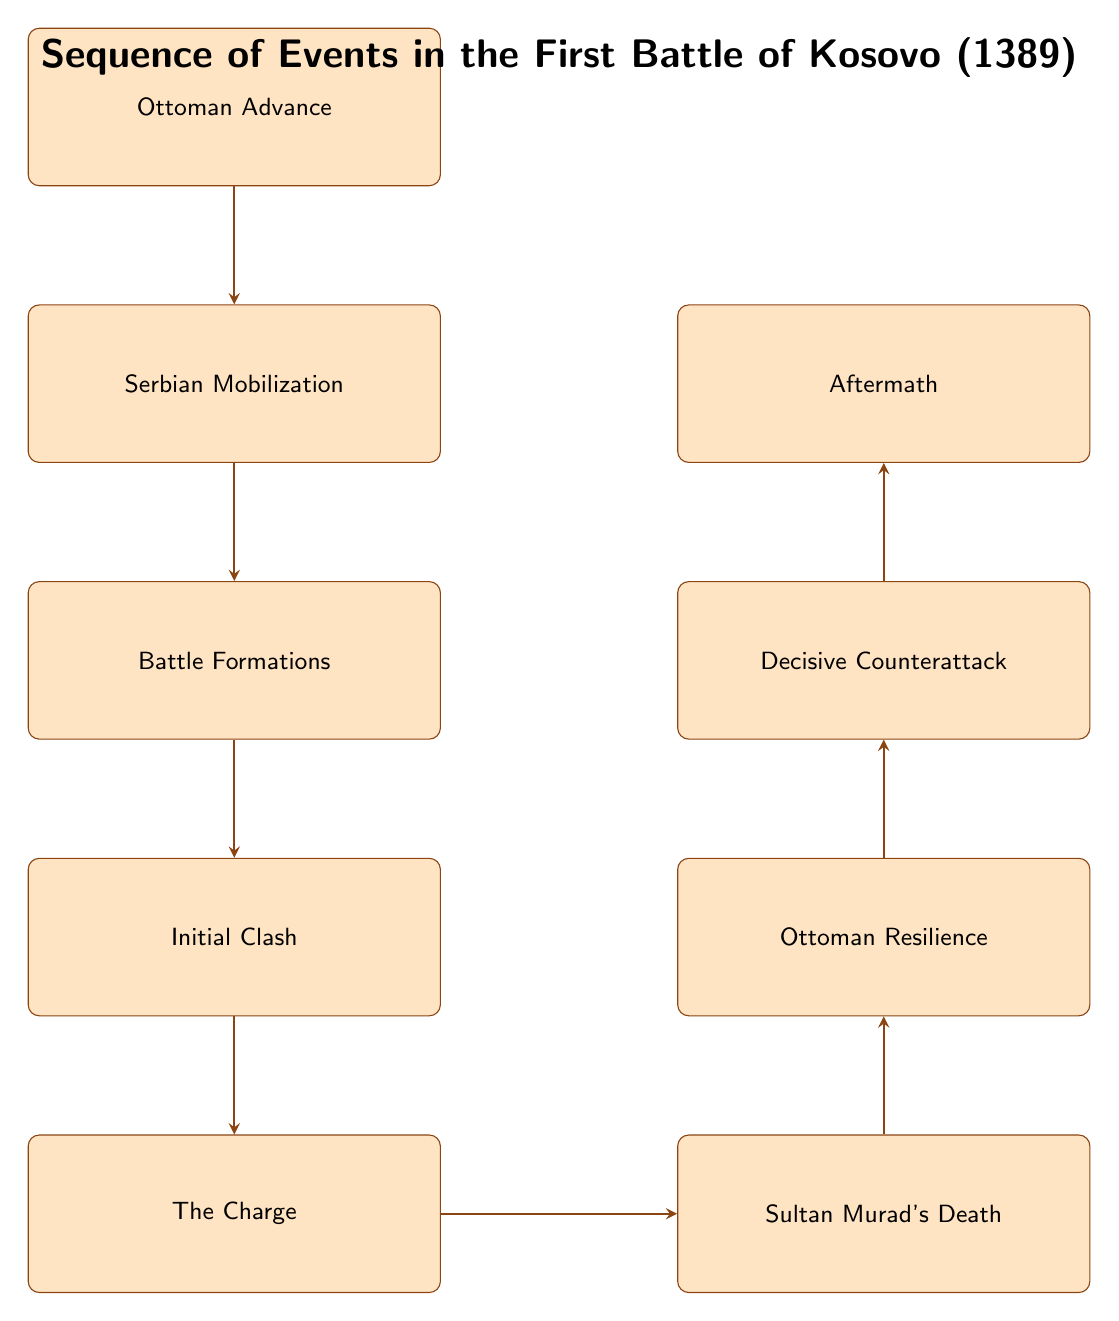What is the first event in the sequence? The first node in the diagram is "Ottoman Advance," indicating it is the starting point of the sequence of events.
Answer: Ottoman Advance How many nodes are there in total? By counting the number of unique events in the diagram, we find there are nine nodes listed sequentially.
Answer: 9 What event follows "Initial Clash"? The arrow leading out from "Initial Clash" points to "The Charge," which indicates that it is the next event in the sequence.
Answer: The Charge Which event involves the assassination of Sultan Murad I? The node "Sultan Murad's Death" directly describes the event in which Sultan Murad I is assassinated.
Answer: Sultan Murad's Death What happens immediately after Sultan Murad's death? Following the node "Sultan Murad's Death," the next event is "Ottoman Resilience," indicating the Ottoman forces regroup after the assassination.
Answer: Ottoman Resilience Who leads the Ottomans after Sultan Murad's death? In the diagram, "Bayezid I" is mentioned in relation to "Ottoman Resilience," indicating he takes over the leadership after Sultan Murad's death.
Answer: Bayezid I What describes the formations of both armies? The "Battle Formations" node summarizes that the Ottomans adopt a crescent formation and the Serbians a defensive line.
Answer: Battle Formations What is the last event recorded in the diagram? The diagram's final node is labeled "Aftermath," which signifies the conclusion of the sequence of events in the battle.
Answer: Aftermath What is the result of the decisive counterattack? The node "Decisive Counterattack" indicates this event led to overwhelming the Serbian forces, resulting in a significant outcome of the battle.
Answer: overwhelming the Serbian forces 